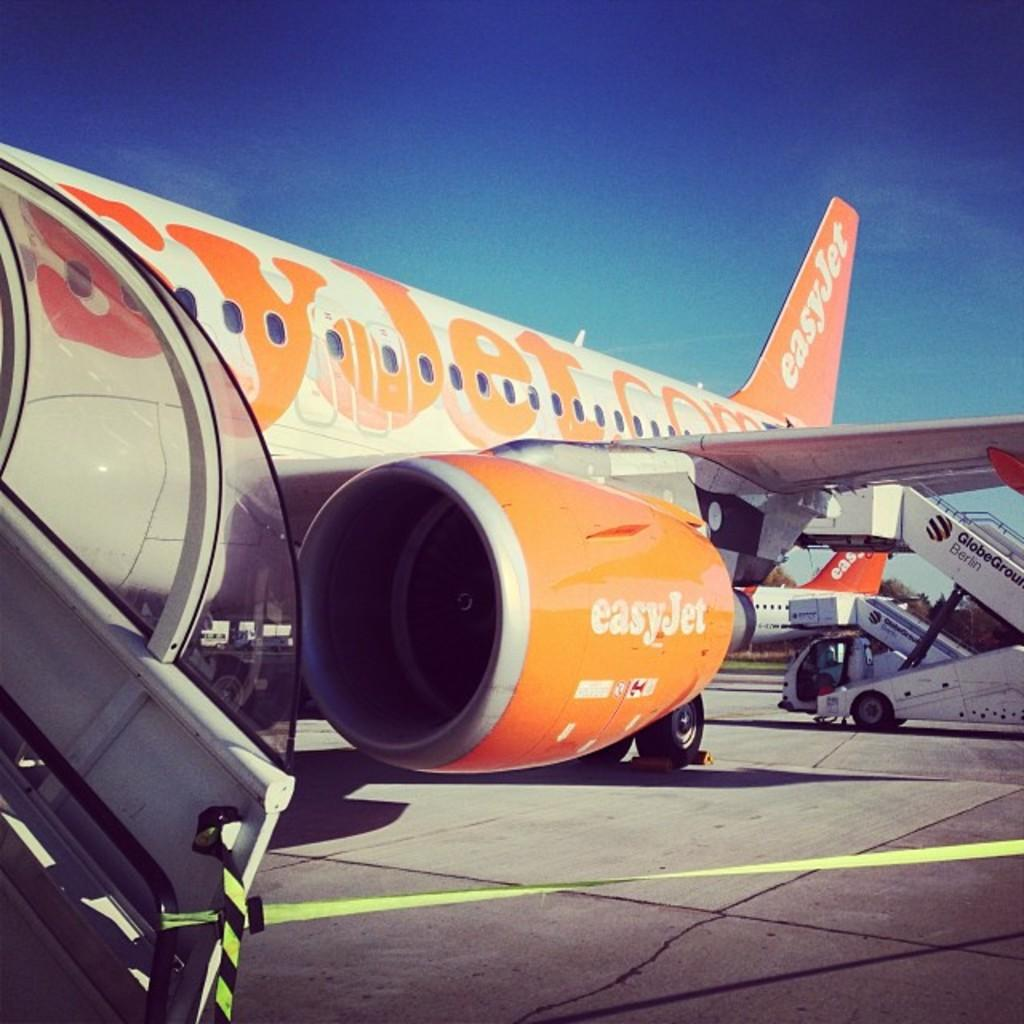<image>
Create a compact narrative representing the image presented. A jet displaying the address to the website easyjet.com 